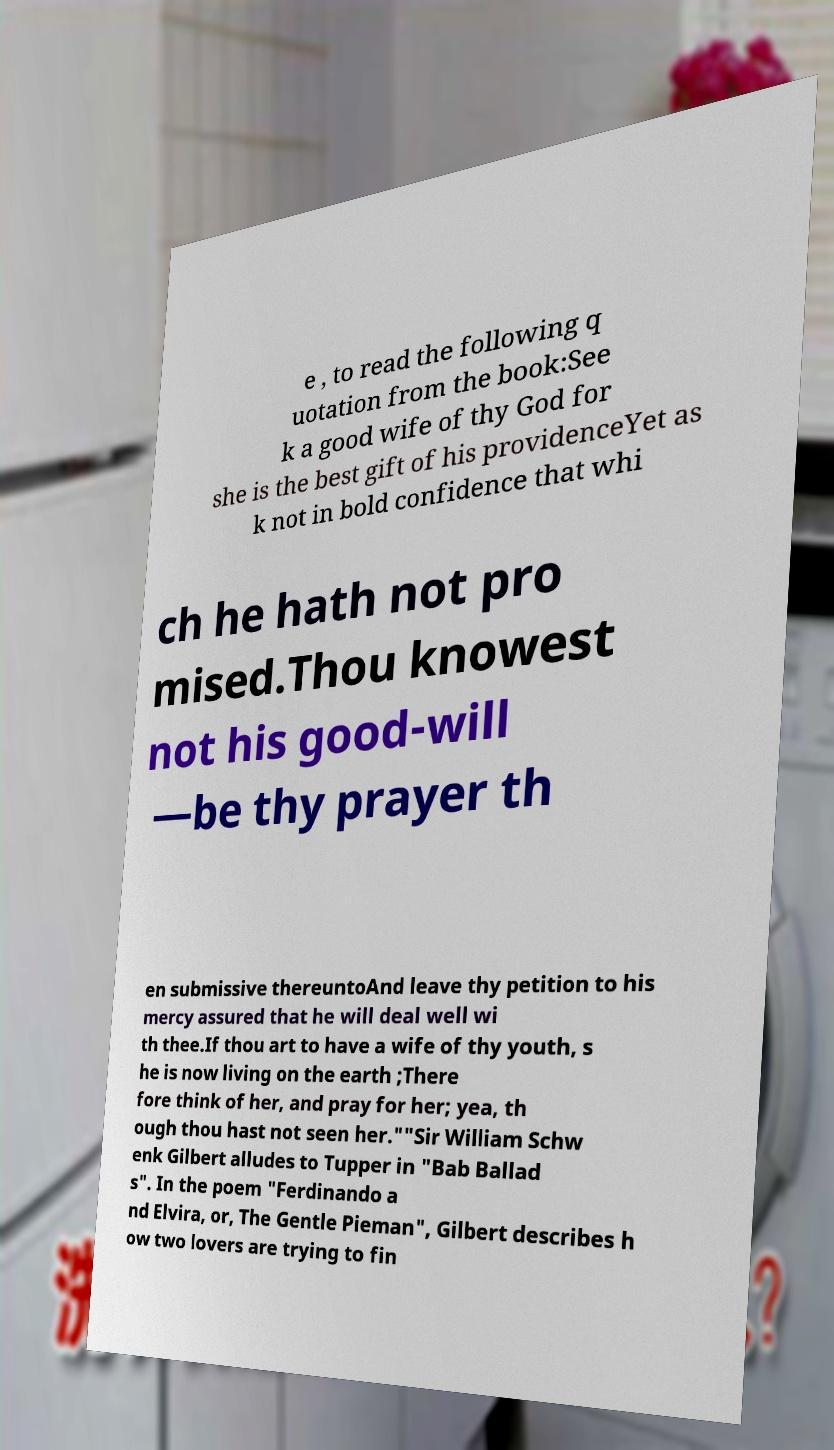Could you assist in decoding the text presented in this image and type it out clearly? e , to read the following q uotation from the book:See k a good wife of thy God for she is the best gift of his providenceYet as k not in bold confidence that whi ch he hath not pro mised.Thou knowest not his good-will —be thy prayer th en submissive thereuntoAnd leave thy petition to his mercy assured that he will deal well wi th thee.If thou art to have a wife of thy youth, s he is now living on the earth ;There fore think of her, and pray for her; yea, th ough thou hast not seen her.""Sir William Schw enk Gilbert alludes to Tupper in "Bab Ballad s". In the poem "Ferdinando a nd Elvira, or, The Gentle Pieman", Gilbert describes h ow two lovers are trying to fin 